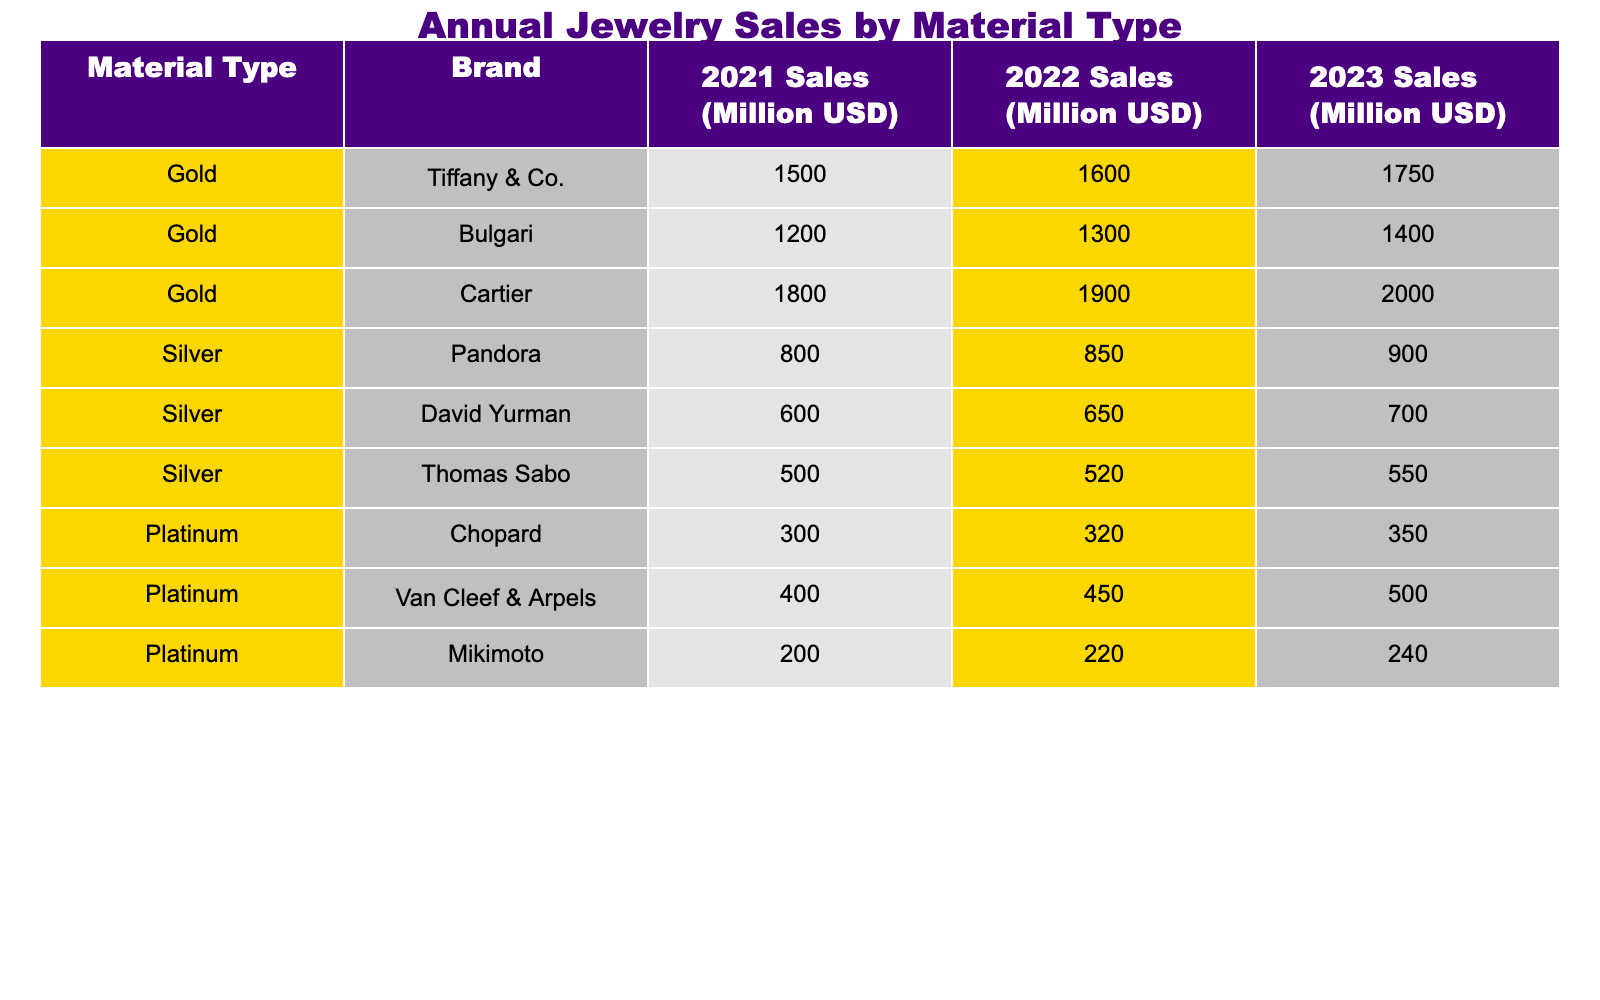What were the total sales for Gold jewelry in 2023? The Gold jewelry sales for 2023 can be found by adding the sales from each brand: Tiffany & Co. (1750 million) + Bulgari (1400 million) + Cartier (2000 million) = 1750 + 1400 + 2000 = 5150 million USD.
Answer: 5150 million USD Which brand had the highest sales in Silver jewelry in 2022? The Silver jewelry sales for 2022 are as follows: Pandora (850 million), David Yurman (650 million), and Thomas Sabo (520 million). The highest sales is from Pandora at 850 million USD.
Answer: Pandora What is the percentage increase in sales for Platinum jewelry from 2021 to 2023? First, we find the sales in 2021 (900 million) and 2023 (500 million). The increase is 500 - 300 = 200 million. The percentage increase is then (200 / 300) * 100 = 66.67%.
Answer: 66.67% Is there any brand with sales equal to or greater than 2000 million USD in 2022? The sales for all brands in 2022 are: Tiffany & Co. (1600 million), Bulgari (1300 million), Cartier (1900 million), Pandora (850 million), David Yurman (650 million), Thomas Sabo (520 million), Chopard (320 million), Van Cleef & Arpels (450 million), and Mikimoto (220 million). None of these sales figures are equal to or greater than 2000 million USD.
Answer: No What is the average sales figure for all brands in Gold jewelry over the three years? To find the average, we first sum the sales for each brand for all three years: (1500 + 1600 + 1750) + (1200 + 1300 + 1400) + (1800 + 1900 + 2000) = 16050 million USD. There are 3 brands, so the average is 16050 / 3 = 5350 million USD.
Answer: 5350 million USD Which material type had the lowest total sales across all years? We sum the total sales for each material: Gold (1500 + 1600 + 1750 + 1200 + 1300 + 1400 + 1800 + 1900 + 2000 = 16400 million), Silver (800 + 850 + 900 + 600 + 650 + 700 + 500 + 520 + 550 = 5250 million), Platinum (300 + 320 + 350 + 400 + 450 + 500 + 200 + 220 + 240 = 3090 million). Thus, Platinum has the lowest sales.
Answer: Platinum How much more did Cartier earn from Gold jewelry in 2023 compared to Chopard in Platinum jewelry for the same year? Cartier earned 2000 million USD in Gold jewelry for 2023, while Chopard earned 350 million USD in Platinum jewelry for the same year. The difference is 2000 - 350 = 1650 million USD.
Answer: 1650 million USD What was the total sales for Silver jewelry across all three years? We add the sales for all three years: (800 + 850 + 900) + (600 + 650 + 700) + (500 + 520 + 550) = 5250 million USD.
Answer: 5250 million USD 